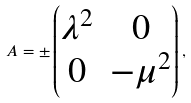Convert formula to latex. <formula><loc_0><loc_0><loc_500><loc_500>A = \pm \begin{pmatrix} \lambda ^ { 2 } & 0 \\ 0 & - \mu ^ { 2 } \end{pmatrix} ,</formula> 